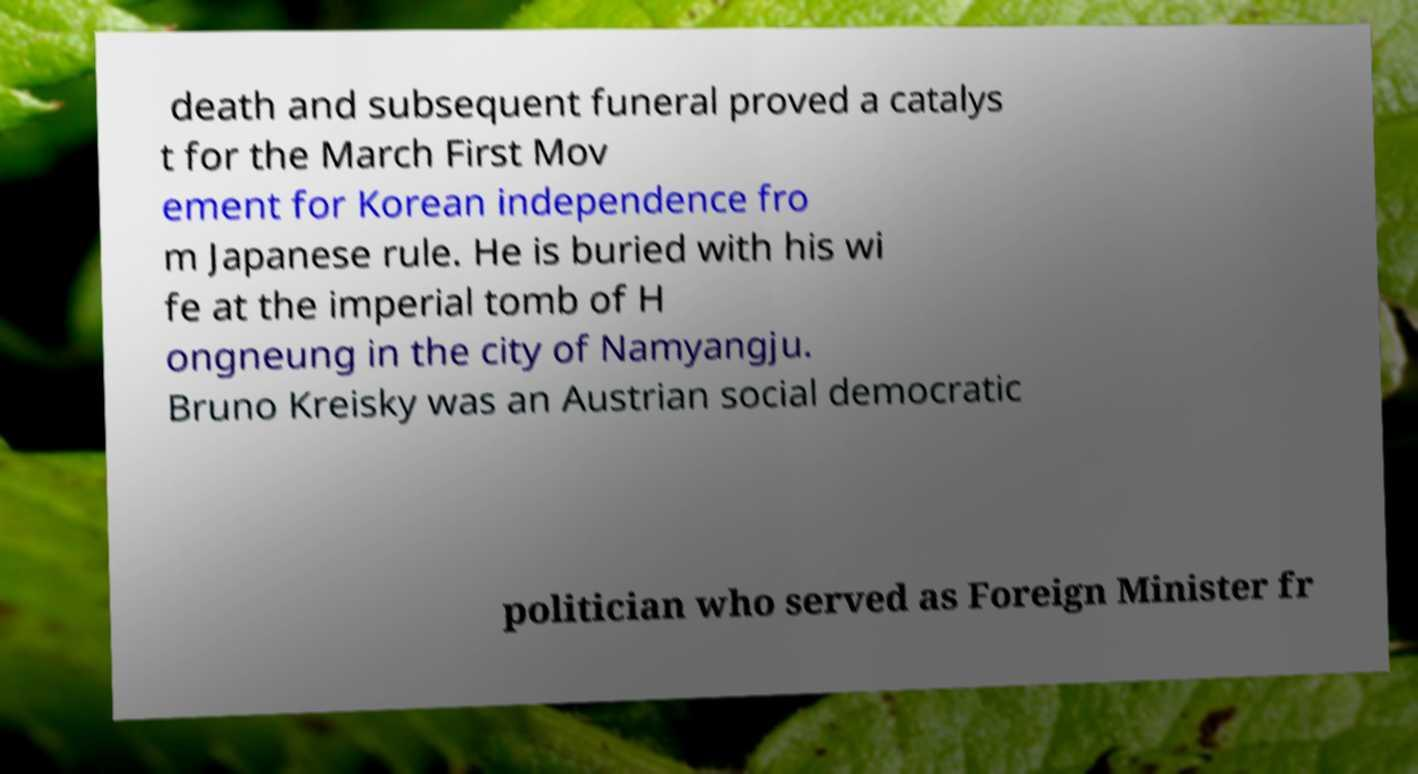I need the written content from this picture converted into text. Can you do that? death and subsequent funeral proved a catalys t for the March First Mov ement for Korean independence fro m Japanese rule. He is buried with his wi fe at the imperial tomb of H ongneung in the city of Namyangju. Bruno Kreisky was an Austrian social democratic politician who served as Foreign Minister fr 